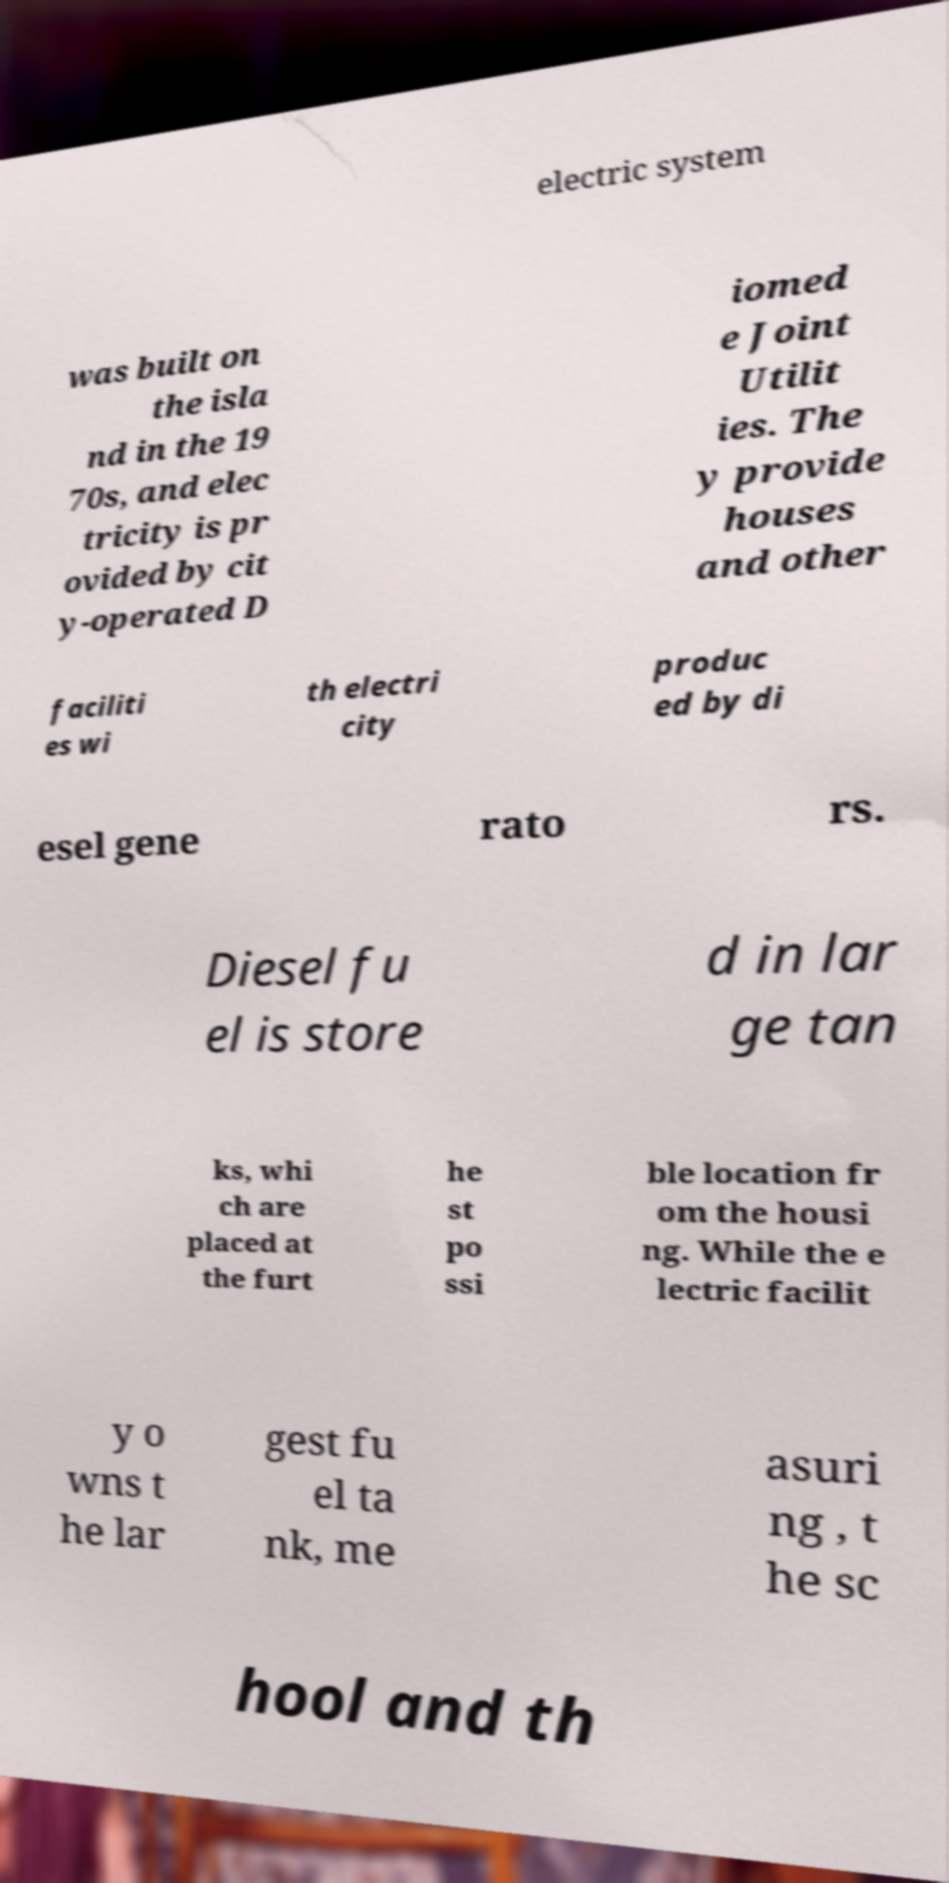For documentation purposes, I need the text within this image transcribed. Could you provide that? electric system was built on the isla nd in the 19 70s, and elec tricity is pr ovided by cit y-operated D iomed e Joint Utilit ies. The y provide houses and other faciliti es wi th electri city produc ed by di esel gene rato rs. Diesel fu el is store d in lar ge tan ks, whi ch are placed at the furt he st po ssi ble location fr om the housi ng. While the e lectric facilit y o wns t he lar gest fu el ta nk, me asuri ng , t he sc hool and th 